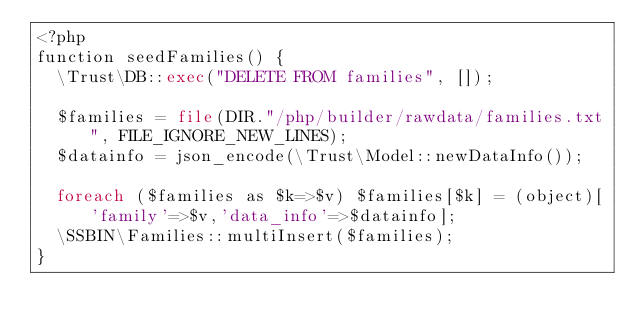<code> <loc_0><loc_0><loc_500><loc_500><_PHP_><?php
function seedFamilies() {
  \Trust\DB::exec("DELETE FROM families", []);

  $families = file(DIR."/php/builder/rawdata/families.txt", FILE_IGNORE_NEW_LINES);
  $datainfo = json_encode(\Trust\Model::newDataInfo());
  
  foreach ($families as $k=>$v) $families[$k] = (object)['family'=>$v,'data_info'=>$datainfo];
  \SSBIN\Families::multiInsert($families);
}
</code> 